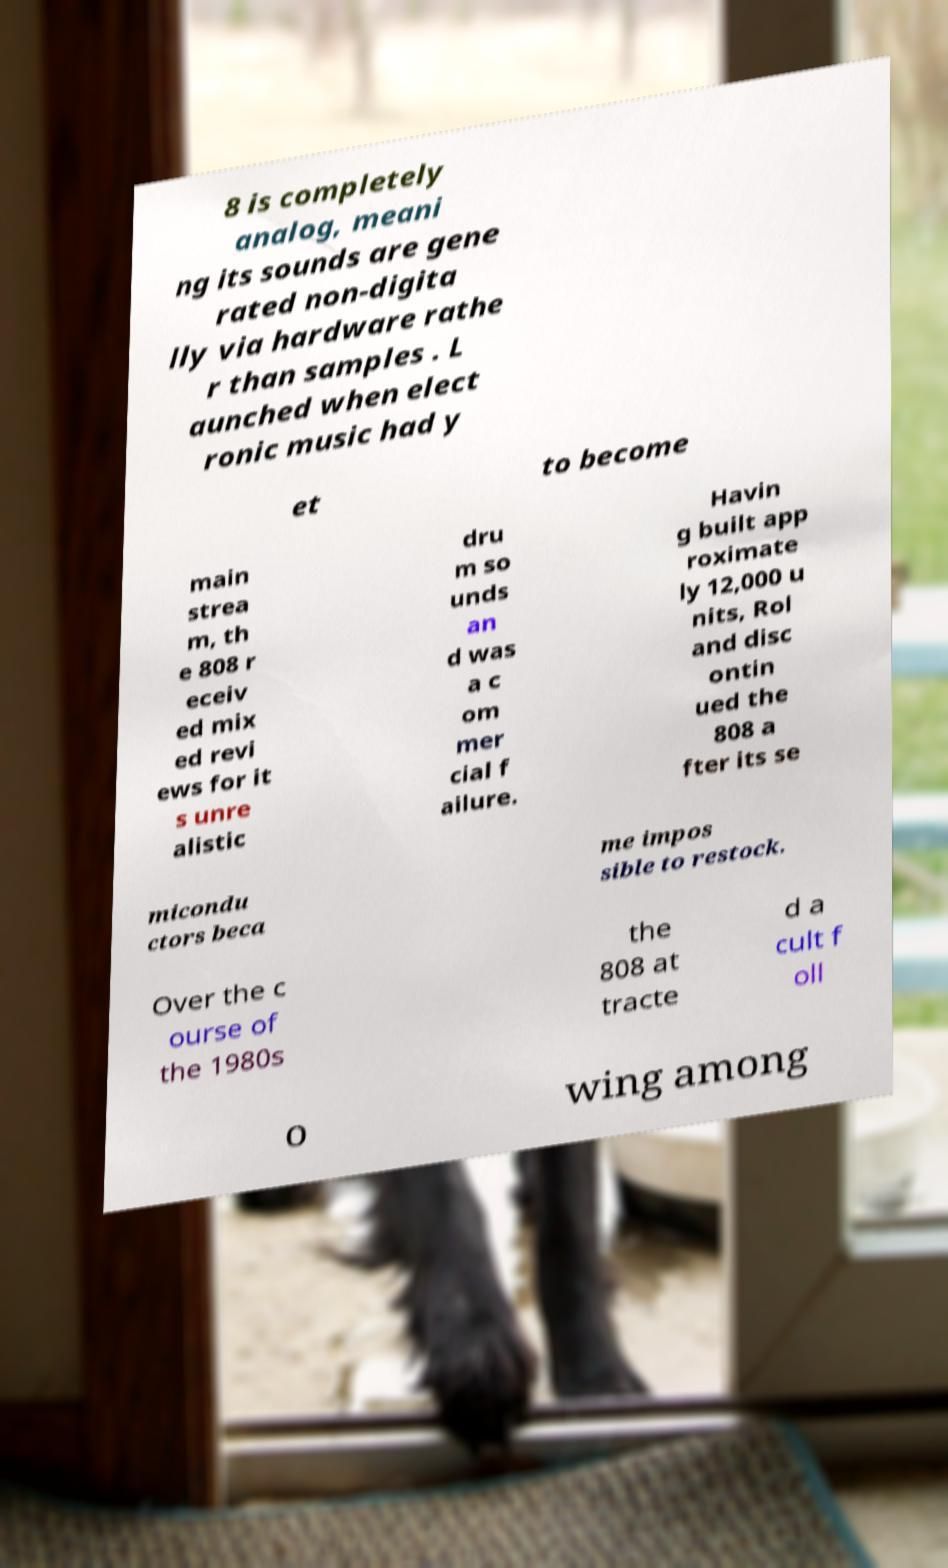What messages or text are displayed in this image? I need them in a readable, typed format. 8 is completely analog, meani ng its sounds are gene rated non-digita lly via hardware rathe r than samples . L aunched when elect ronic music had y et to become main strea m, th e 808 r eceiv ed mix ed revi ews for it s unre alistic dru m so unds an d was a c om mer cial f ailure. Havin g built app roximate ly 12,000 u nits, Rol and disc ontin ued the 808 a fter its se micondu ctors beca me impos sible to restock. Over the c ourse of the 1980s the 808 at tracte d a cult f oll o wing among 